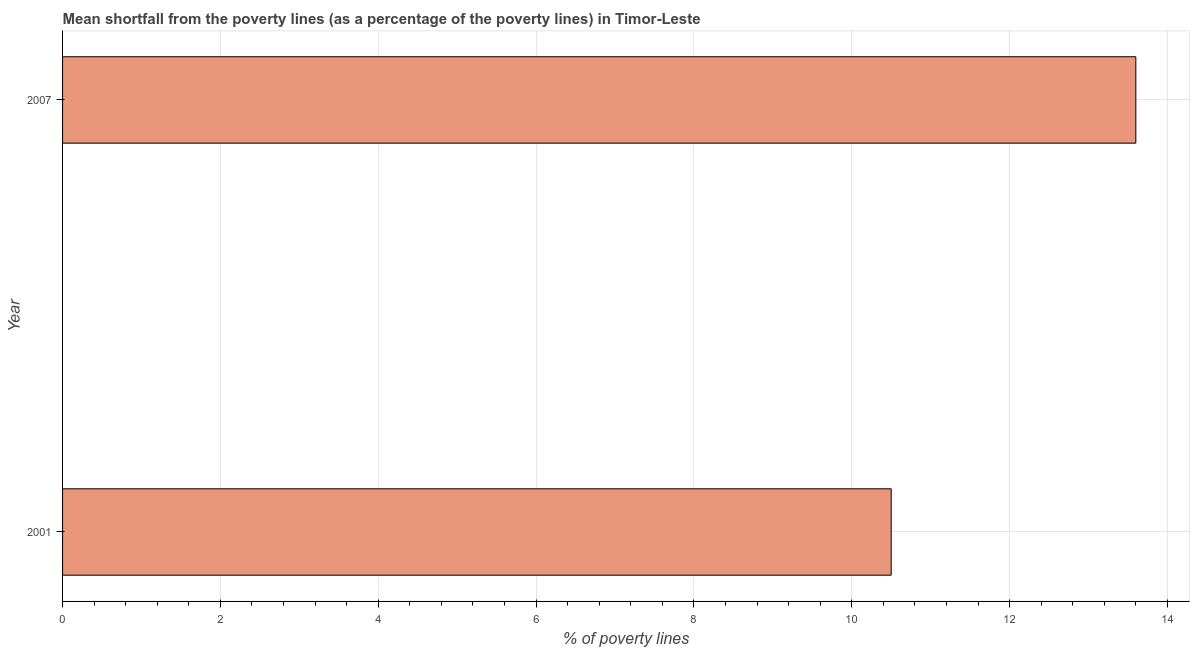What is the title of the graph?
Your answer should be very brief. Mean shortfall from the poverty lines (as a percentage of the poverty lines) in Timor-Leste. What is the label or title of the X-axis?
Keep it short and to the point. % of poverty lines. Across all years, what is the maximum poverty gap at national poverty lines?
Your response must be concise. 13.6. Across all years, what is the minimum poverty gap at national poverty lines?
Make the answer very short. 10.5. In which year was the poverty gap at national poverty lines minimum?
Offer a terse response. 2001. What is the sum of the poverty gap at national poverty lines?
Provide a succinct answer. 24.1. What is the average poverty gap at national poverty lines per year?
Give a very brief answer. 12.05. What is the median poverty gap at national poverty lines?
Make the answer very short. 12.05. In how many years, is the poverty gap at national poverty lines greater than 13.6 %?
Offer a terse response. 0. Do a majority of the years between 2001 and 2007 (inclusive) have poverty gap at national poverty lines greater than 8.8 %?
Your answer should be compact. Yes. What is the ratio of the poverty gap at national poverty lines in 2001 to that in 2007?
Provide a succinct answer. 0.77. Is the poverty gap at national poverty lines in 2001 less than that in 2007?
Make the answer very short. Yes. Are the values on the major ticks of X-axis written in scientific E-notation?
Your response must be concise. No. What is the % of poverty lines in 2007?
Your response must be concise. 13.6. What is the ratio of the % of poverty lines in 2001 to that in 2007?
Make the answer very short. 0.77. 